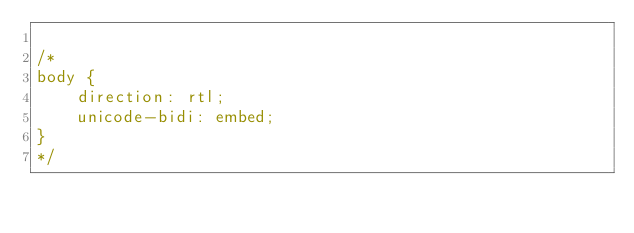Convert code to text. <code><loc_0><loc_0><loc_500><loc_500><_CSS_>
/*
body {
	direction: rtl;
	unicode-bidi: embed;
}
*/</code> 